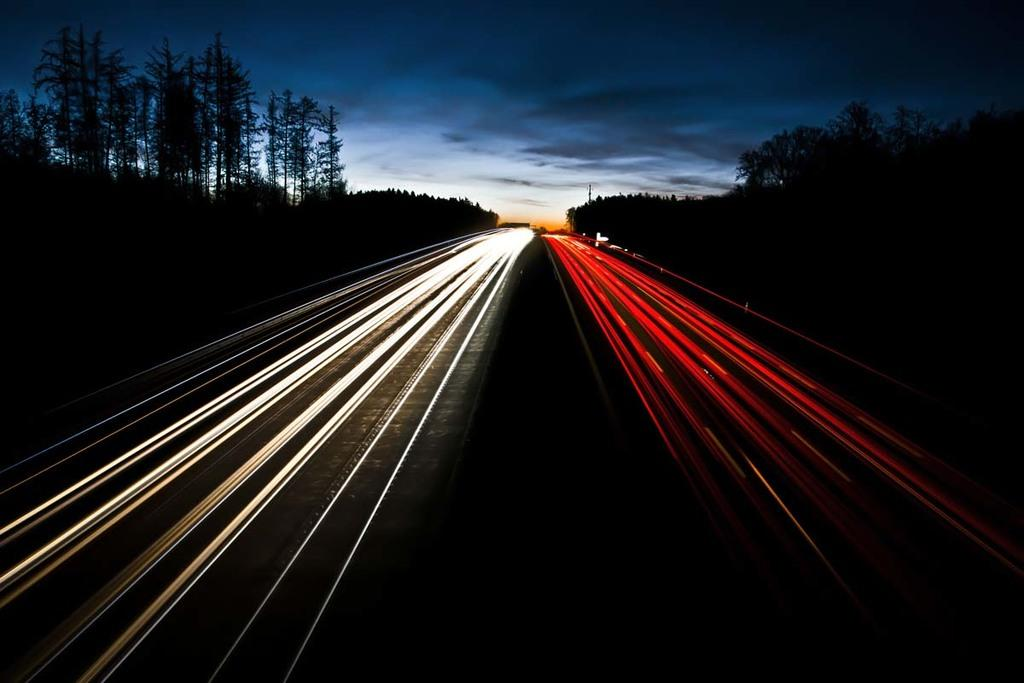What type of man-made structures can be seen in the image? There are roads in the image. What type of natural elements are present in the image? There are trees in the image. What object is standing upright in the image? There is a pole in the image. What is visible in the background of the image? The sky is visible in the background of the image. Can you tell me how many slices of pie are on the pole in the image? There is no pie present in the image, and the pole does not have any slices on it. What type of growth can be seen on the trees in the image? There is no mention of growth on the trees in the image, and the provided facts do not give any information about the trees' condition. 